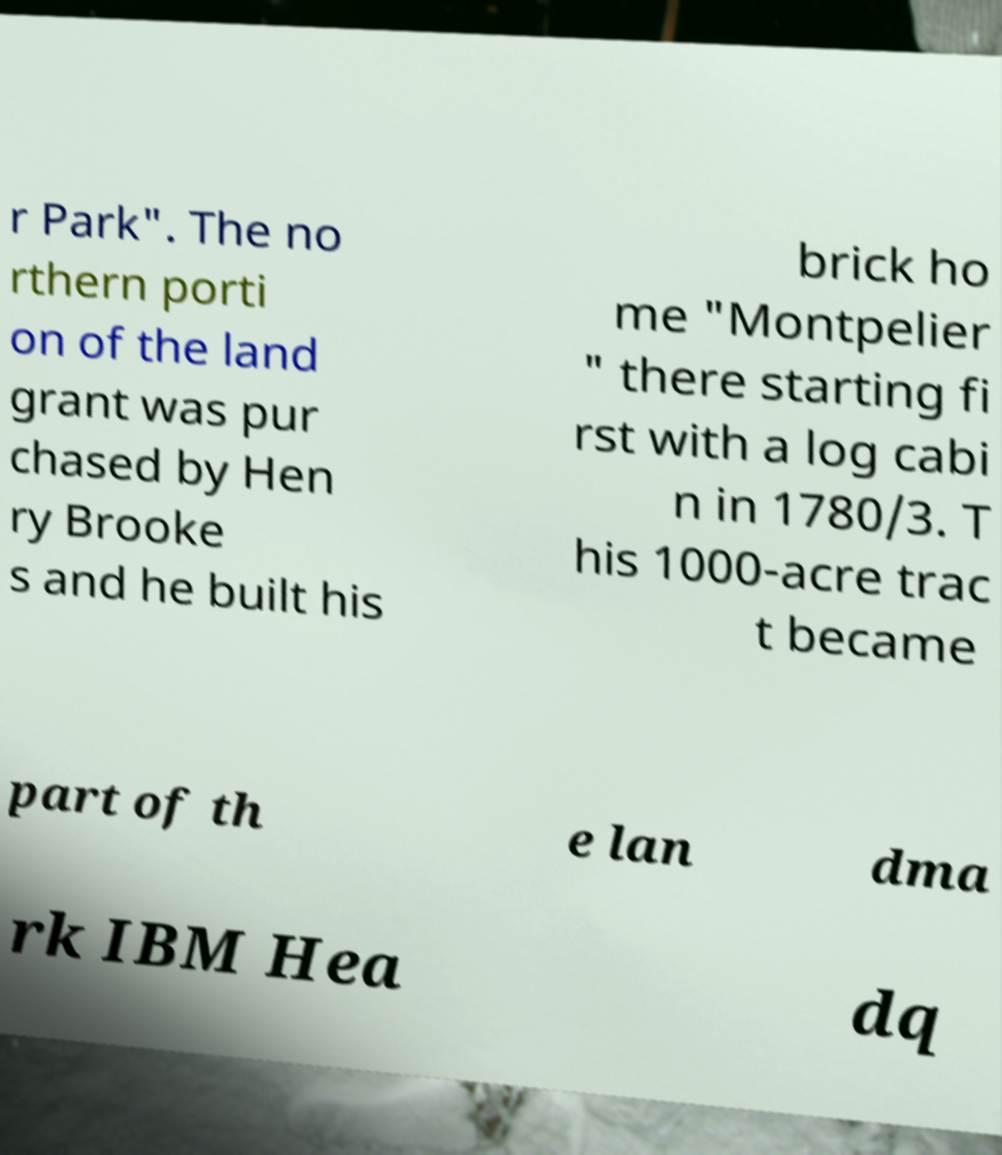Could you extract and type out the text from this image? r Park". The no rthern porti on of the land grant was pur chased by Hen ry Brooke s and he built his brick ho me "Montpelier " there starting fi rst with a log cabi n in 1780/3. T his 1000-acre trac t became part of th e lan dma rk IBM Hea dq 